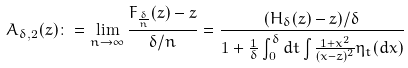Convert formula to latex. <formula><loc_0><loc_0><loc_500><loc_500>A _ { \delta , 2 } ( z ) \colon = \lim _ { n \to \infty } \frac { F _ { \frac { \delta } { n } } ( z ) - z } { \delta / n } = \frac { ( H _ { \delta } ( z ) - z ) / \delta } { 1 + \frac { 1 } { \delta } \int _ { 0 } ^ { \delta } d t \int _ { \real } \frac { 1 + x ^ { 2 } } { ( x - z ) ^ { 2 } } \eta _ { t } ( d x ) }</formula> 